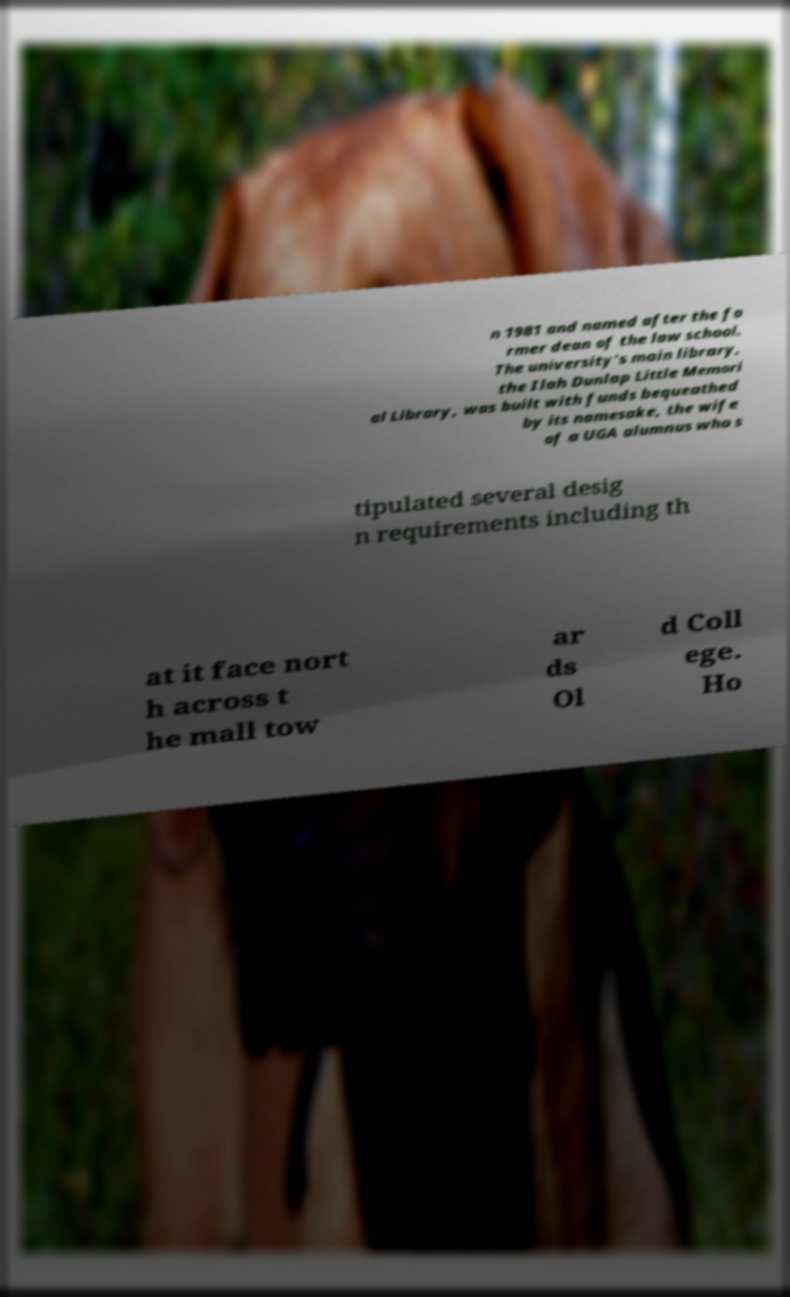For documentation purposes, I need the text within this image transcribed. Could you provide that? n 1981 and named after the fo rmer dean of the law school. The university's main library, the Ilah Dunlap Little Memori al Library, was built with funds bequeathed by its namesake, the wife of a UGA alumnus who s tipulated several desig n requirements including th at it face nort h across t he mall tow ar ds Ol d Coll ege. Ho 